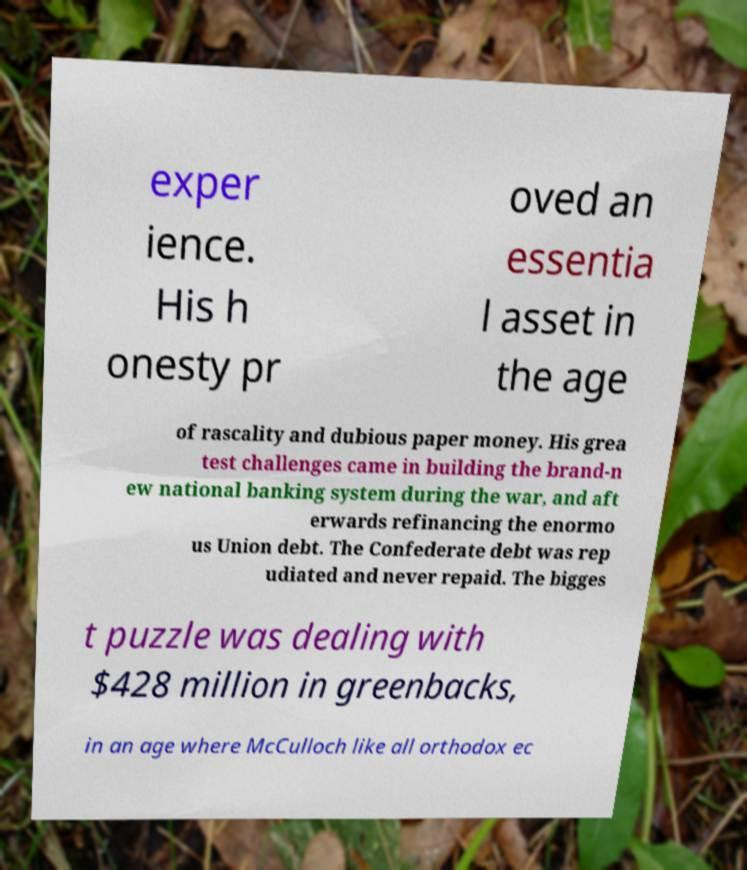Could you assist in decoding the text presented in this image and type it out clearly? exper ience. His h onesty pr oved an essentia l asset in the age of rascality and dubious paper money. His grea test challenges came in building the brand-n ew national banking system during the war, and aft erwards refinancing the enormo us Union debt. The Confederate debt was rep udiated and never repaid. The bigges t puzzle was dealing with $428 million in greenbacks, in an age where McCulloch like all orthodox ec 